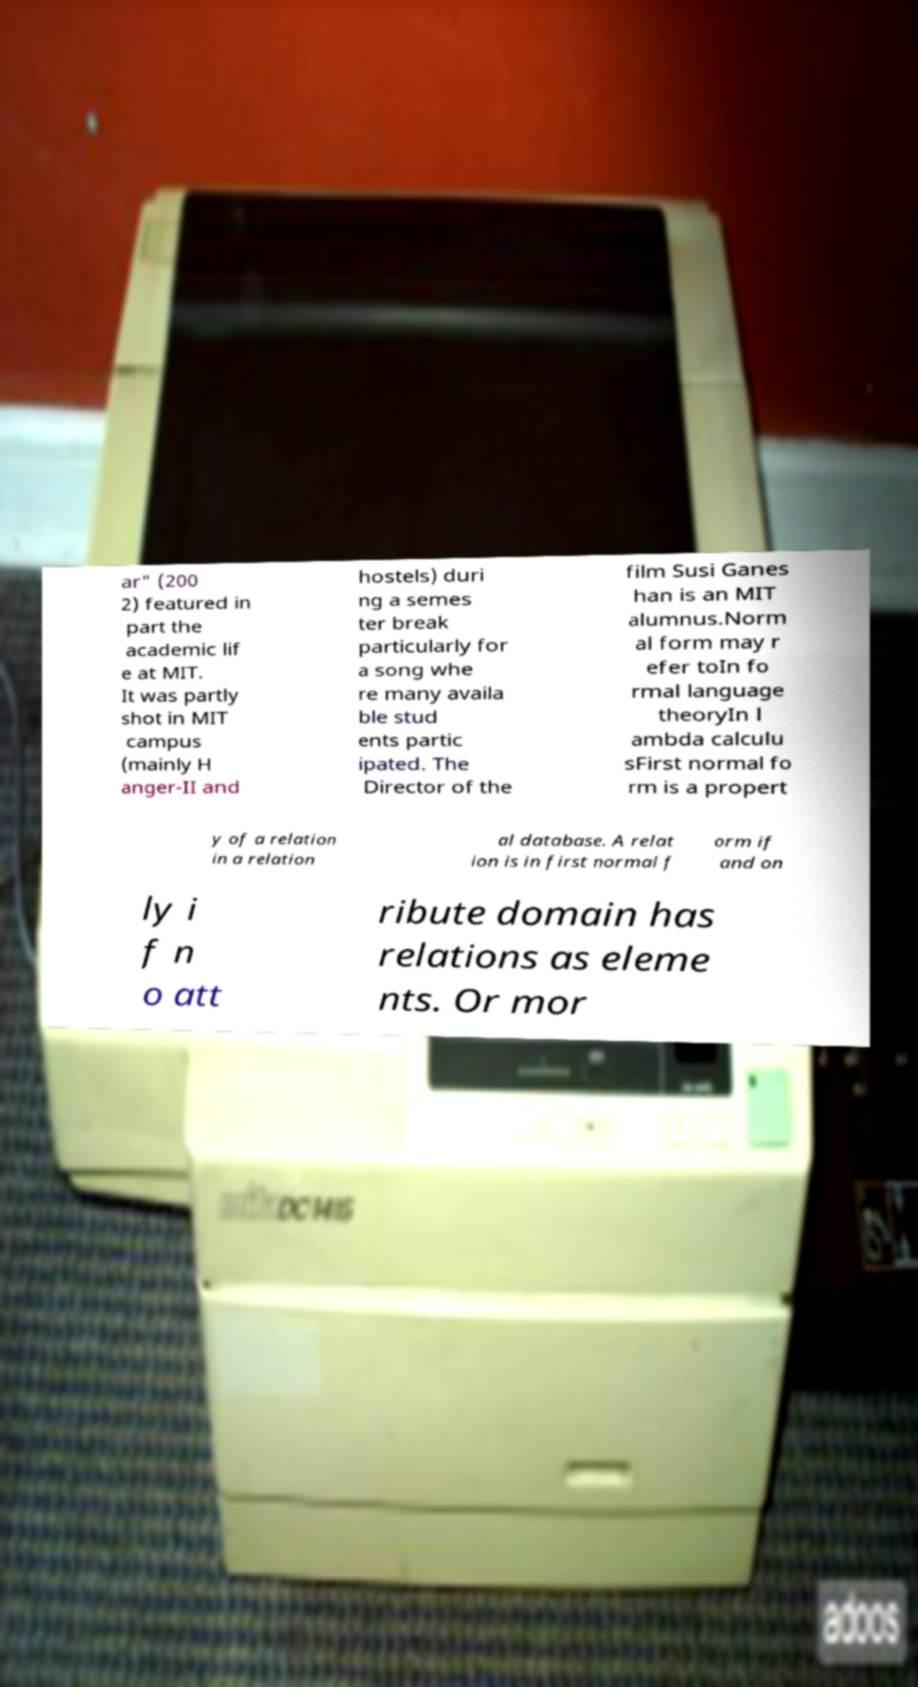Could you assist in decoding the text presented in this image and type it out clearly? ar" (200 2) featured in part the academic lif e at MIT. It was partly shot in MIT campus (mainly H anger-II and hostels) duri ng a semes ter break particularly for a song whe re many availa ble stud ents partic ipated. The Director of the film Susi Ganes han is an MIT alumnus.Norm al form may r efer toIn fo rmal language theoryIn l ambda calculu sFirst normal fo rm is a propert y of a relation in a relation al database. A relat ion is in first normal f orm if and on ly i f n o att ribute domain has relations as eleme nts. Or mor 